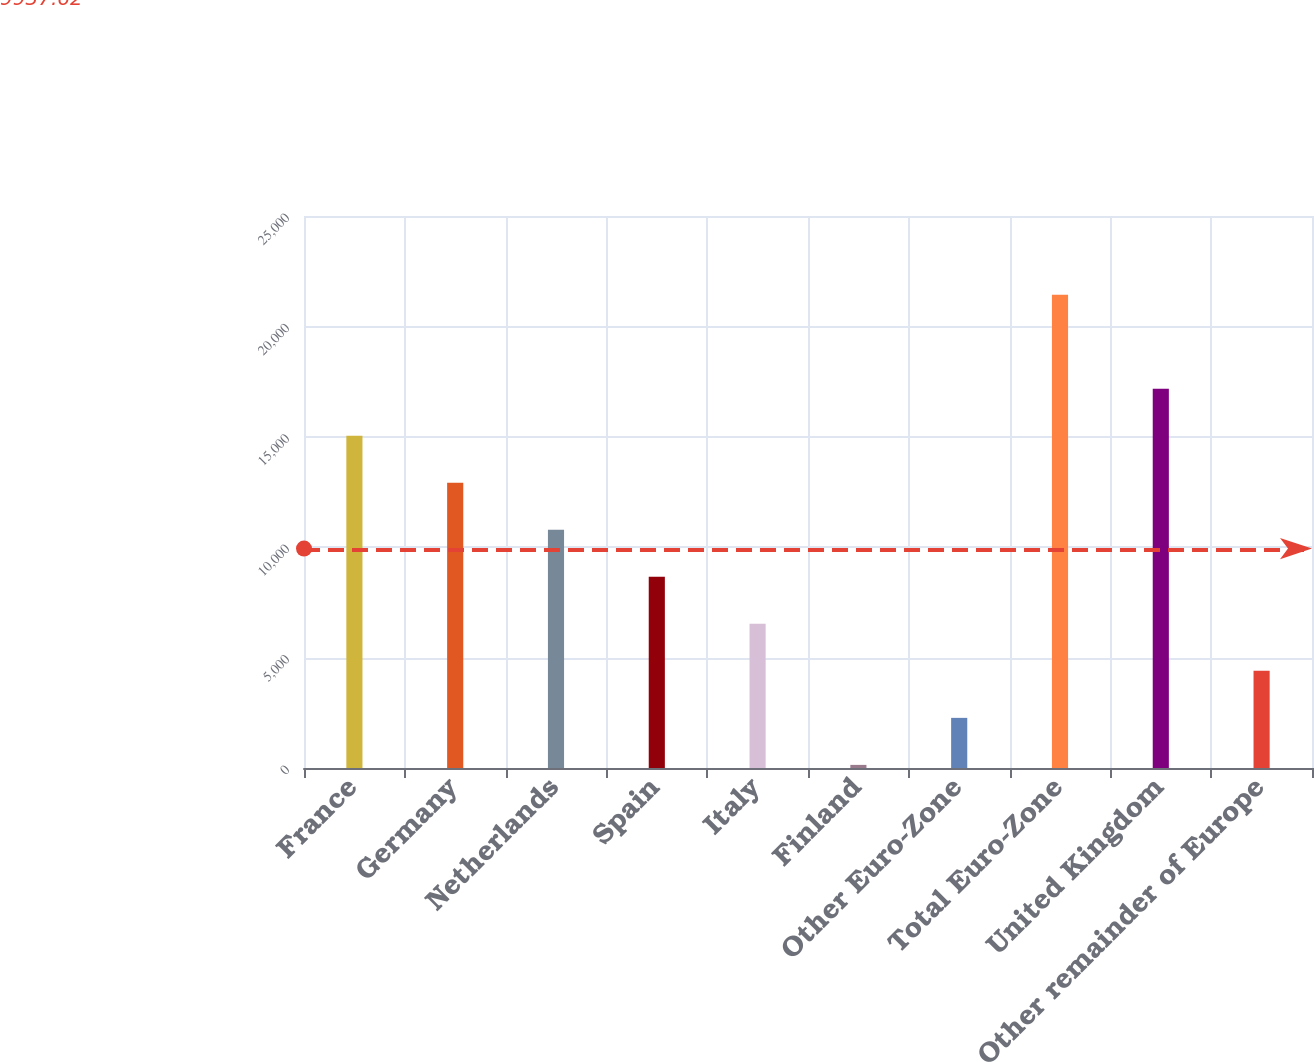Convert chart to OTSL. <chart><loc_0><loc_0><loc_500><loc_500><bar_chart><fcel>France<fcel>Germany<fcel>Netherlands<fcel>Spain<fcel>Italy<fcel>Finland<fcel>Other Euro-Zone<fcel>Total Euro-Zone<fcel>United Kingdom<fcel>Other remainder of Europe<nl><fcel>15048.9<fcel>12919.2<fcel>10789.5<fcel>8659.8<fcel>6530.1<fcel>141<fcel>2270.7<fcel>21438<fcel>17178.6<fcel>4400.4<nl></chart> 